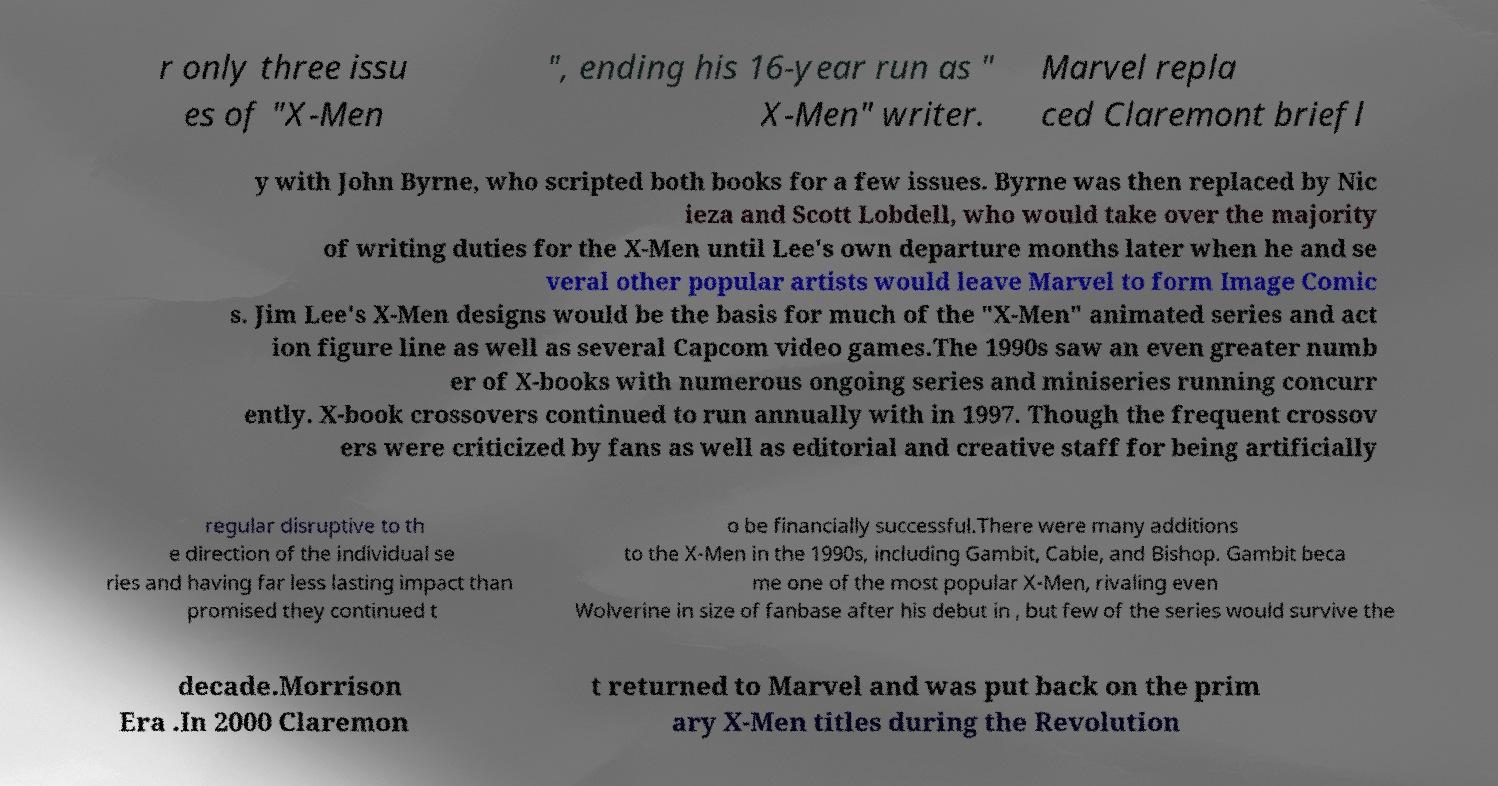What messages or text are displayed in this image? I need them in a readable, typed format. r only three issu es of "X-Men ", ending his 16-year run as " X-Men" writer. Marvel repla ced Claremont briefl y with John Byrne, who scripted both books for a few issues. Byrne was then replaced by Nic ieza and Scott Lobdell, who would take over the majority of writing duties for the X-Men until Lee's own departure months later when he and se veral other popular artists would leave Marvel to form Image Comic s. Jim Lee's X-Men designs would be the basis for much of the "X-Men" animated series and act ion figure line as well as several Capcom video games.The 1990s saw an even greater numb er of X-books with numerous ongoing series and miniseries running concurr ently. X-book crossovers continued to run annually with in 1997. Though the frequent crossov ers were criticized by fans as well as editorial and creative staff for being artificially regular disruptive to th e direction of the individual se ries and having far less lasting impact than promised they continued t o be financially successful.There were many additions to the X-Men in the 1990s, including Gambit, Cable, and Bishop. Gambit beca me one of the most popular X-Men, rivaling even Wolverine in size of fanbase after his debut in , but few of the series would survive the decade.Morrison Era .In 2000 Claremon t returned to Marvel and was put back on the prim ary X-Men titles during the Revolution 